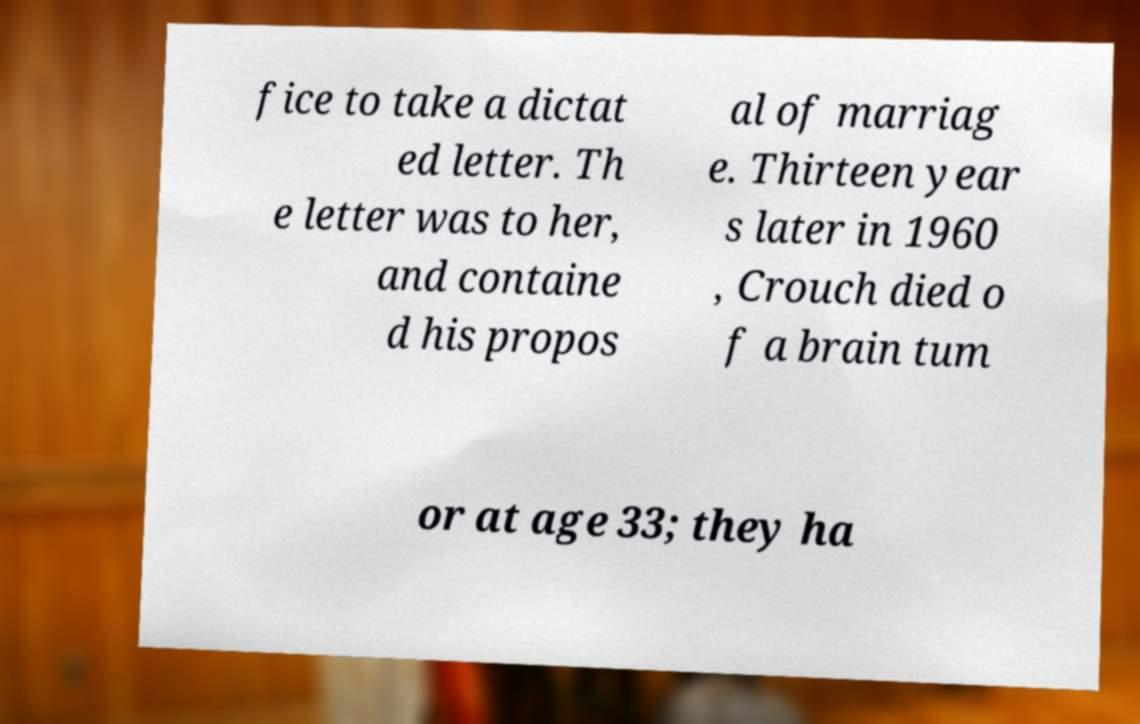There's text embedded in this image that I need extracted. Can you transcribe it verbatim? fice to take a dictat ed letter. Th e letter was to her, and containe d his propos al of marriag e. Thirteen year s later in 1960 , Crouch died o f a brain tum or at age 33; they ha 